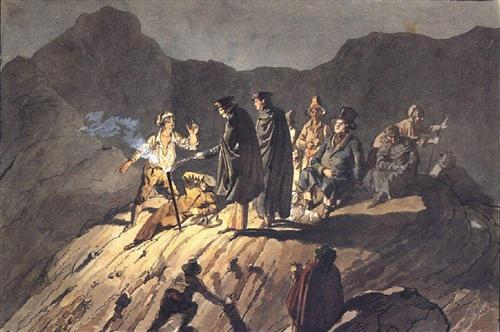What is this photo about? The image depicts a dramatic and possibly historical scene set in a rugged mountainous terrain. It features a group of people dressed in period clothing, suggesting an event from the past. The dark, moody color palette and the dynamic poses of the figures enhance the tension and emotional intensity of the scene. This painting likely represents a critical moment in a historical narrative, possibly depicting a battle or a pivotal confrontation. Details such as the varied expressions, the atmospheric perspective, and the striking use of light and shadow draw the viewer into the action, making this a compelling example of Romantic-era art, which valued emotion, individualism, and the sublime beauty of nature. 